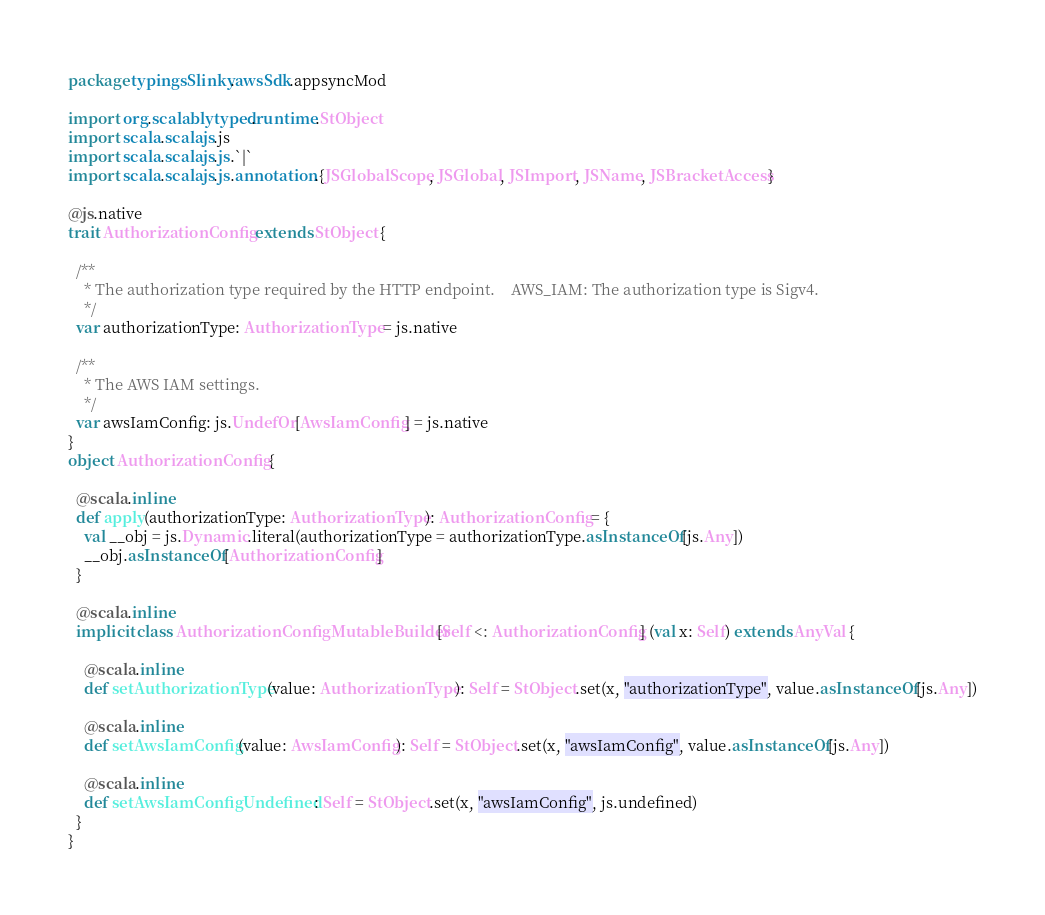Convert code to text. <code><loc_0><loc_0><loc_500><loc_500><_Scala_>package typingsSlinky.awsSdk.appsyncMod

import org.scalablytyped.runtime.StObject
import scala.scalajs.js
import scala.scalajs.js.`|`
import scala.scalajs.js.annotation.{JSGlobalScope, JSGlobal, JSImport, JSName, JSBracketAccess}

@js.native
trait AuthorizationConfig extends StObject {
  
  /**
    * The authorization type required by the HTTP endpoint.    AWS_IAM: The authorization type is Sigv4.  
    */
  var authorizationType: AuthorizationType = js.native
  
  /**
    * The AWS IAM settings.
    */
  var awsIamConfig: js.UndefOr[AwsIamConfig] = js.native
}
object AuthorizationConfig {
  
  @scala.inline
  def apply(authorizationType: AuthorizationType): AuthorizationConfig = {
    val __obj = js.Dynamic.literal(authorizationType = authorizationType.asInstanceOf[js.Any])
    __obj.asInstanceOf[AuthorizationConfig]
  }
  
  @scala.inline
  implicit class AuthorizationConfigMutableBuilder[Self <: AuthorizationConfig] (val x: Self) extends AnyVal {
    
    @scala.inline
    def setAuthorizationType(value: AuthorizationType): Self = StObject.set(x, "authorizationType", value.asInstanceOf[js.Any])
    
    @scala.inline
    def setAwsIamConfig(value: AwsIamConfig): Self = StObject.set(x, "awsIamConfig", value.asInstanceOf[js.Any])
    
    @scala.inline
    def setAwsIamConfigUndefined: Self = StObject.set(x, "awsIamConfig", js.undefined)
  }
}
</code> 